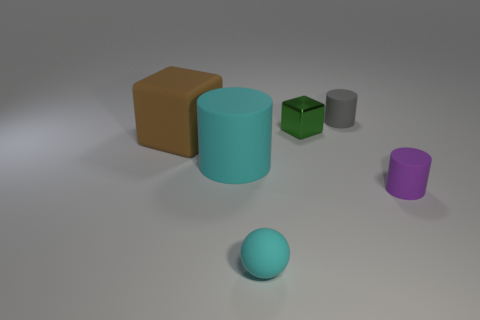Add 3 large brown metal balls. How many objects exist? 9 Subtract all cubes. How many objects are left? 4 Add 4 matte things. How many matte things exist? 9 Subtract 1 cyan spheres. How many objects are left? 5 Subtract all tiny purple things. Subtract all tiny green blocks. How many objects are left? 4 Add 6 small matte balls. How many small matte balls are left? 7 